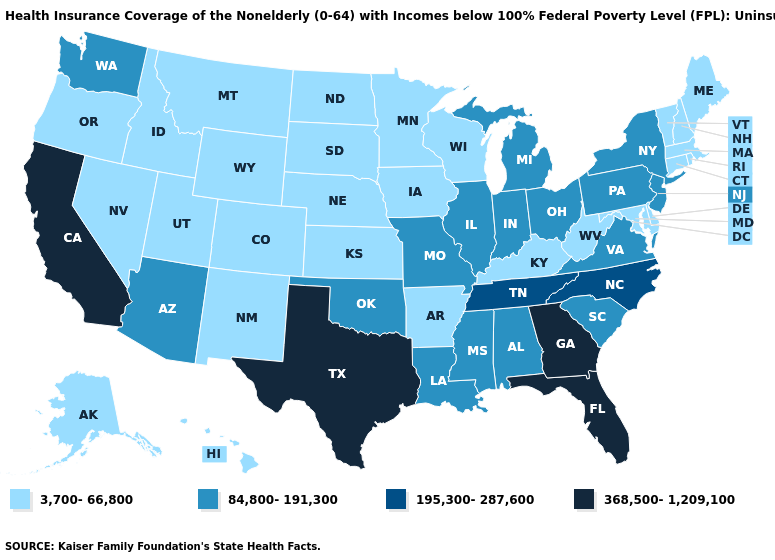What is the value of Alaska?
Be succinct. 3,700-66,800. What is the value of North Carolina?
Short answer required. 195,300-287,600. What is the value of Idaho?
Concise answer only. 3,700-66,800. Does Utah have a higher value than Oklahoma?
Answer briefly. No. What is the value of Oklahoma?
Be succinct. 84,800-191,300. Which states have the lowest value in the Northeast?
Be succinct. Connecticut, Maine, Massachusetts, New Hampshire, Rhode Island, Vermont. Which states have the lowest value in the South?
Write a very short answer. Arkansas, Delaware, Kentucky, Maryland, West Virginia. What is the value of Wyoming?
Answer briefly. 3,700-66,800. What is the value of Mississippi?
Quick response, please. 84,800-191,300. Does the map have missing data?
Quick response, please. No. Among the states that border Missouri , does Tennessee have the highest value?
Quick response, please. Yes. What is the lowest value in the West?
Write a very short answer. 3,700-66,800. Does Utah have the lowest value in the USA?
Give a very brief answer. Yes. Which states hav the highest value in the Northeast?
Write a very short answer. New Jersey, New York, Pennsylvania. What is the lowest value in the MidWest?
Keep it brief. 3,700-66,800. 